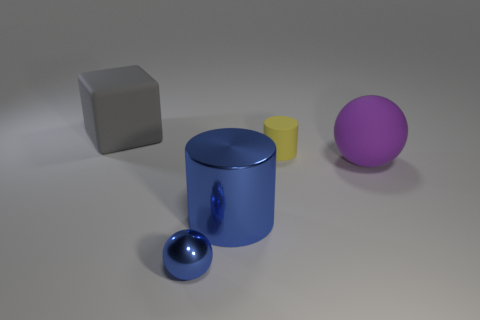What number of green rubber cylinders have the same size as the yellow object?
Your response must be concise. 0. What shape is the thing that is the same color as the metal cylinder?
Provide a succinct answer. Sphere. How many things are either objects in front of the gray rubber block or yellow rubber things?
Provide a succinct answer. 4. Are there fewer small cyan matte cylinders than small blue metallic objects?
Ensure brevity in your answer.  Yes. There is a big object that is the same material as the large ball; what is its shape?
Provide a short and direct response. Cube. Are there any cylinders to the right of the large cylinder?
Offer a very short reply. Yes. Is the number of small blue balls that are behind the large blue shiny cylinder less than the number of large brown rubber cylinders?
Ensure brevity in your answer.  No. What is the block made of?
Keep it short and to the point. Rubber. What is the color of the small cylinder?
Provide a short and direct response. Yellow. The large object that is behind the blue shiny cylinder and on the left side of the big purple sphere is what color?
Provide a succinct answer. Gray. 